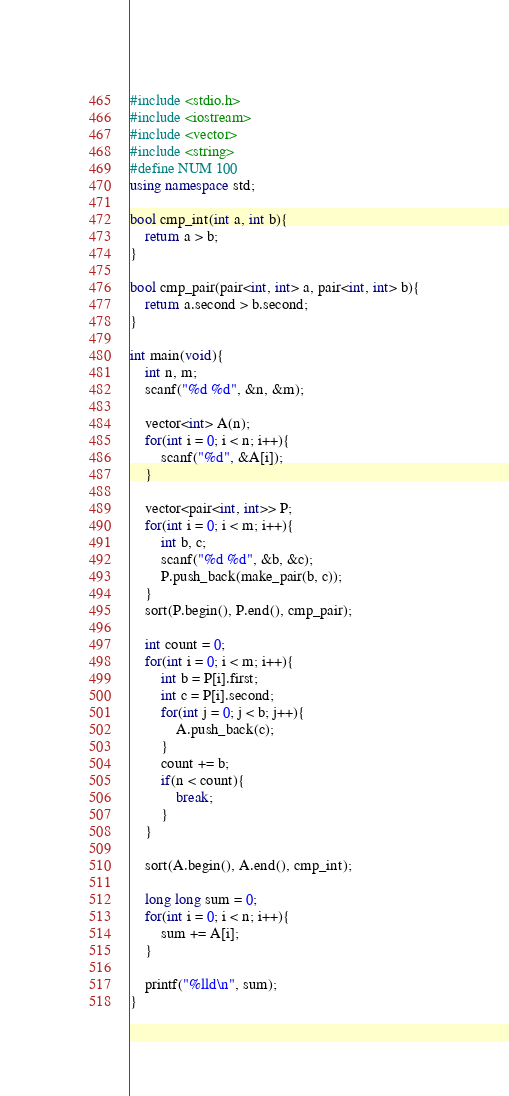Convert code to text. <code><loc_0><loc_0><loc_500><loc_500><_C++_>#include <stdio.h>
#include <iostream>
#include <vector>
#include <string>
#define NUM 100
using namespace std;

bool cmp_int(int a, int b){
    return a > b;
}

bool cmp_pair(pair<int, int> a, pair<int, int> b){
    return a.second > b.second;
}

int main(void){
    int n, m;
    scanf("%d %d", &n, &m);

    vector<int> A(n);
    for(int i = 0; i < n; i++){
        scanf("%d", &A[i]);
    }

    vector<pair<int, int>> P;
    for(int i = 0; i < m; i++){
        int b, c;
        scanf("%d %d", &b, &c);
        P.push_back(make_pair(b, c));
    }
    sort(P.begin(), P.end(), cmp_pair);

    int count = 0;
    for(int i = 0; i < m; i++){
        int b = P[i].first;
        int c = P[i].second;
        for(int j = 0; j < b; j++){
            A.push_back(c);
        }
        count += b;
        if(n < count){
            break;
        }
    }

    sort(A.begin(), A.end(), cmp_int);

    long long sum = 0;
    for(int i = 0; i < n; i++){
        sum += A[i];
    }

    printf("%lld\n", sum);
}
</code> 